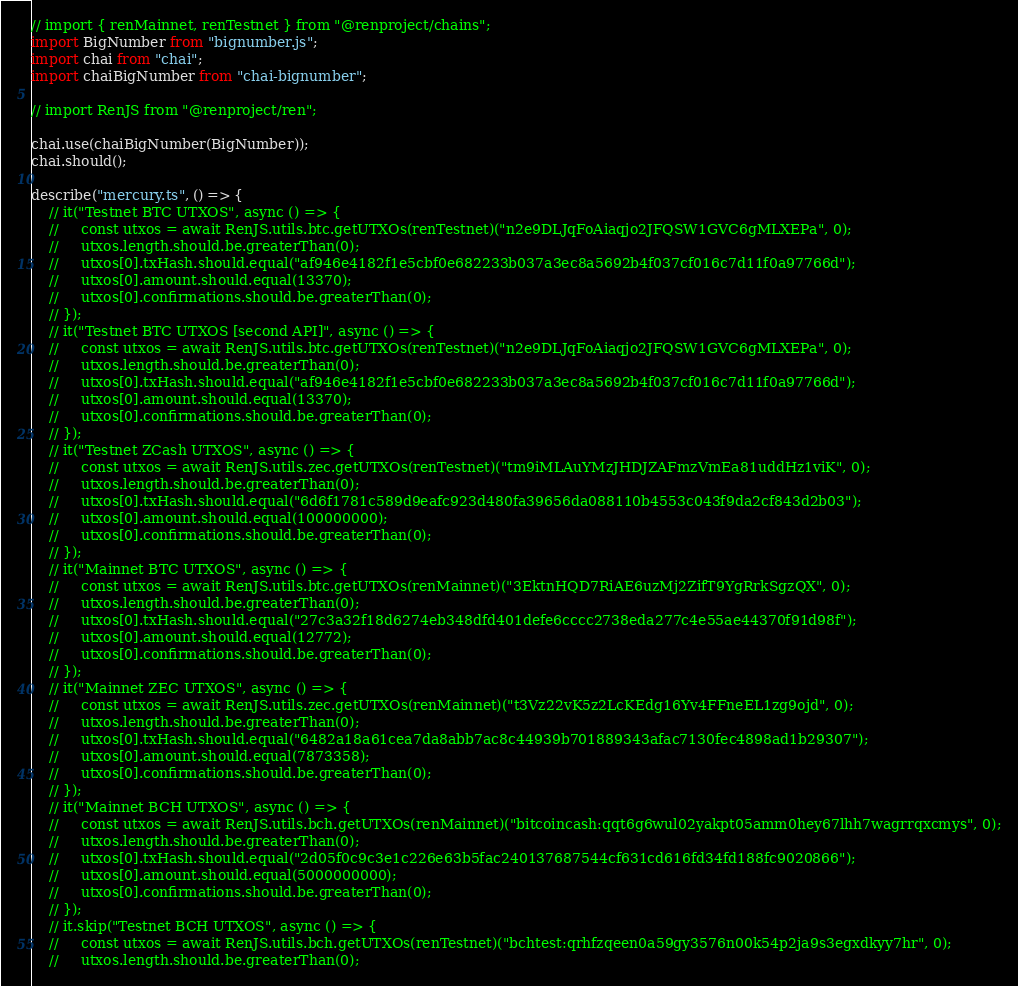Convert code to text. <code><loc_0><loc_0><loc_500><loc_500><_TypeScript_>// import { renMainnet, renTestnet } from "@renproject/chains";
import BigNumber from "bignumber.js";
import chai from "chai";
import chaiBigNumber from "chai-bignumber";

// import RenJS from "@renproject/ren";

chai.use(chaiBigNumber(BigNumber));
chai.should();

describe("mercury.ts", () => {
    // it("Testnet BTC UTXOS", async () => {
    //     const utxos = await RenJS.utils.btc.getUTXOs(renTestnet)("n2e9DLJqFoAiaqjo2JFQSW1GVC6gMLXEPa", 0);
    //     utxos.length.should.be.greaterThan(0);
    //     utxos[0].txHash.should.equal("af946e4182f1e5cbf0e682233b037a3ec8a5692b4f037cf016c7d11f0a97766d");
    //     utxos[0].amount.should.equal(13370);
    //     utxos[0].confirmations.should.be.greaterThan(0);
    // });
    // it("Testnet BTC UTXOS [second API]", async () => {
    //     const utxos = await RenJS.utils.btc.getUTXOs(renTestnet)("n2e9DLJqFoAiaqjo2JFQSW1GVC6gMLXEPa", 0);
    //     utxos.length.should.be.greaterThan(0);
    //     utxos[0].txHash.should.equal("af946e4182f1e5cbf0e682233b037a3ec8a5692b4f037cf016c7d11f0a97766d");
    //     utxos[0].amount.should.equal(13370);
    //     utxos[0].confirmations.should.be.greaterThan(0);
    // });
    // it("Testnet ZCash UTXOS", async () => {
    //     const utxos = await RenJS.utils.zec.getUTXOs(renTestnet)("tm9iMLAuYMzJHDJZAFmzVmEa81uddHz1viK", 0);
    //     utxos.length.should.be.greaterThan(0);
    //     utxos[0].txHash.should.equal("6d6f1781c589d9eafc923d480fa39656da088110b4553c043f9da2cf843d2b03");
    //     utxos[0].amount.should.equal(100000000);
    //     utxos[0].confirmations.should.be.greaterThan(0);
    // });
    // it("Mainnet BTC UTXOS", async () => {
    //     const utxos = await RenJS.utils.btc.getUTXOs(renMainnet)("3EktnHQD7RiAE6uzMj2ZifT9YgRrkSgzQX", 0);
    //     utxos.length.should.be.greaterThan(0);
    //     utxos[0].txHash.should.equal("27c3a32f18d6274eb348dfd401defe6cccc2738eda277c4e55ae44370f91d98f");
    //     utxos[0].amount.should.equal(12772);
    //     utxos[0].confirmations.should.be.greaterThan(0);
    // });
    // it("Mainnet ZEC UTXOS", async () => {
    //     const utxos = await RenJS.utils.zec.getUTXOs(renMainnet)("t3Vz22vK5z2LcKEdg16Yv4FFneEL1zg9ojd", 0);
    //     utxos.length.should.be.greaterThan(0);
    //     utxos[0].txHash.should.equal("6482a18a61cea7da8abb7ac8c44939b701889343afac7130fec4898ad1b29307");
    //     utxos[0].amount.should.equal(7873358);
    //     utxos[0].confirmations.should.be.greaterThan(0);
    // });
    // it("Mainnet BCH UTXOS", async () => {
    //     const utxos = await RenJS.utils.bch.getUTXOs(renMainnet)("bitcoincash:qqt6g6wul02yakpt05amm0hey67lhh7wagrrqxcmys", 0);
    //     utxos.length.should.be.greaterThan(0);
    //     utxos[0].txHash.should.equal("2d05f0c9c3e1c226e63b5fac240137687544cf631cd616fd34fd188fc9020866");
    //     utxos[0].amount.should.equal(5000000000);
    //     utxos[0].confirmations.should.be.greaterThan(0);
    // });
    // it.skip("Testnet BCH UTXOS", async () => {
    //     const utxos = await RenJS.utils.bch.getUTXOs(renTestnet)("bchtest:qrhfzqeen0a59gy3576n00k54p2ja9s3egxdkyy7hr", 0);
    //     utxos.length.should.be.greaterThan(0);</code> 